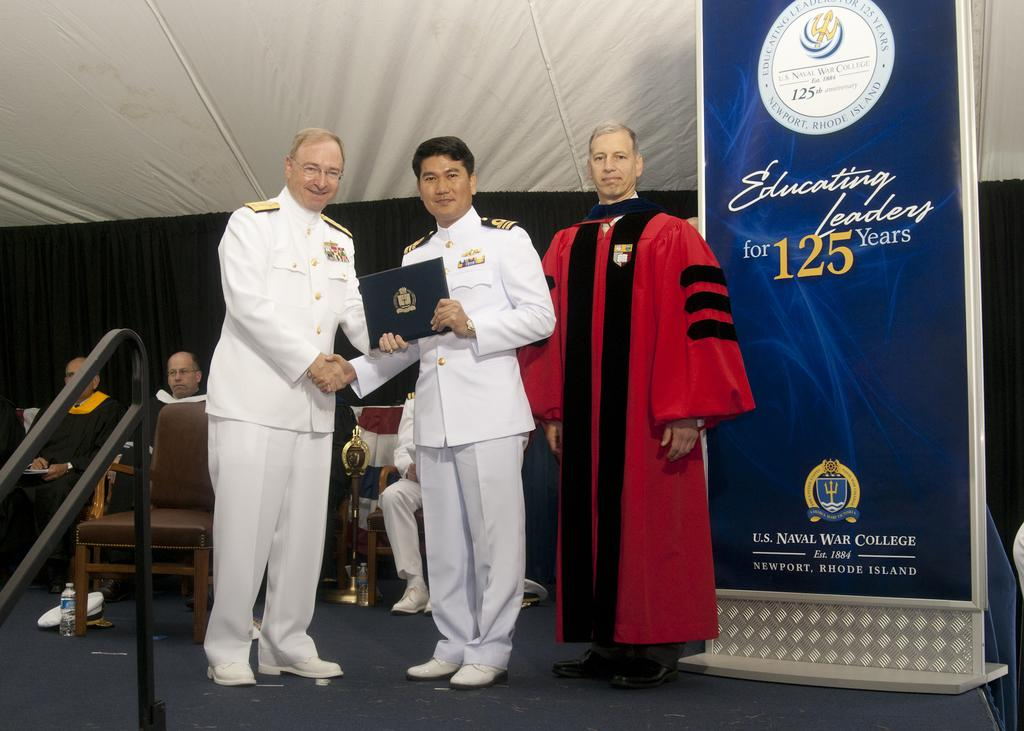How many people are standing on the path in the image? There are three people standing on the path in the image. What are some people doing in the image? Some people are sitting on chairs in the image. What is visible behind the people? There is a banner and a black cloth behind the people. Can you see any frogs hopping on the path in the image? There are no frogs visible in the image. What season is it in the image, given the presence of spring flowers? There is no mention of spring flowers or any seasonal indicators in the image. 